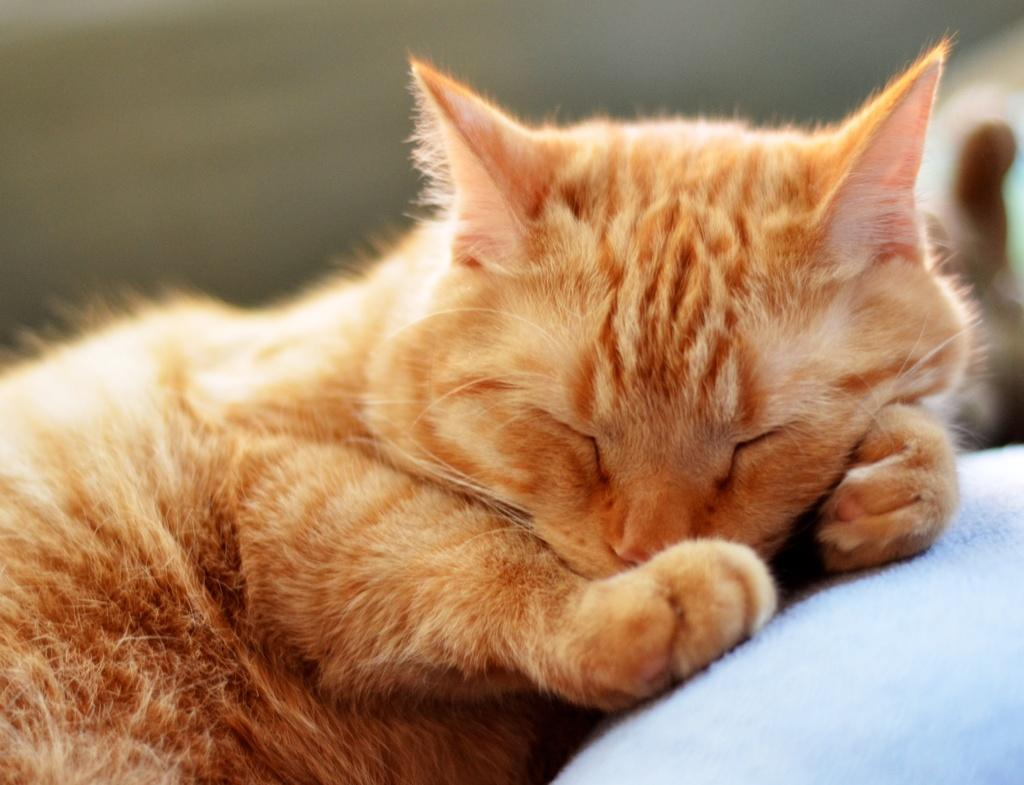What type of animal is in the image? There is a cat in the image. Where is the cat located in the image? The cat is laying on a bed. What type of print can be seen on the cat's pancake in the image? There is no pancake or print present in the image; it features a cat laying on a bed. 